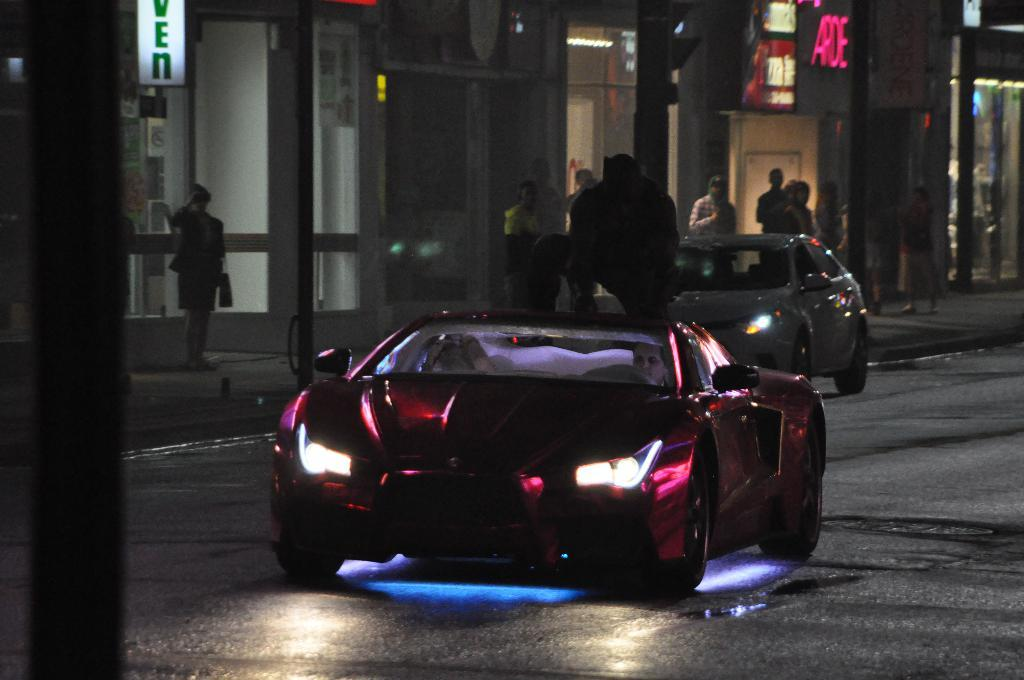What can be seen on the road in the image? There are two cars on the road in the image. What is visible in the background of the image? There are many people and buildings in the background of the image. Can you describe the person sitting on one of the cars? Yes, a person is sitting on one of the cars in the image. What type of music can be heard coming from the cornfield in the image? There is no cornfield or music present in the image. 